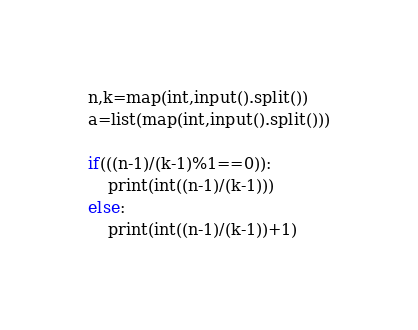<code> <loc_0><loc_0><loc_500><loc_500><_Python_>n,k=map(int,input().split())
a=list(map(int,input().split()))

if(((n-1)/(k-1)%1==0)):
    print(int((n-1)/(k-1)))
else:
    print(int((n-1)/(k-1))+1)</code> 